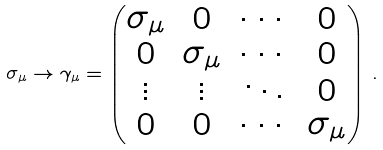Convert formula to latex. <formula><loc_0><loc_0><loc_500><loc_500>\sigma _ { \mu } \rightarrow \gamma _ { \mu } = \begin{pmatrix} \sigma _ { \mu } & 0 & \cdots & 0 \\ 0 & \sigma _ { \mu } & \cdots & 0 \\ \vdots & \vdots & \ddots & 0 \\ 0 & 0 & \cdots & \sigma _ { \mu } \end{pmatrix} \, .</formula> 